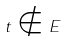Convert formula to latex. <formula><loc_0><loc_0><loc_500><loc_500>t \notin E</formula> 